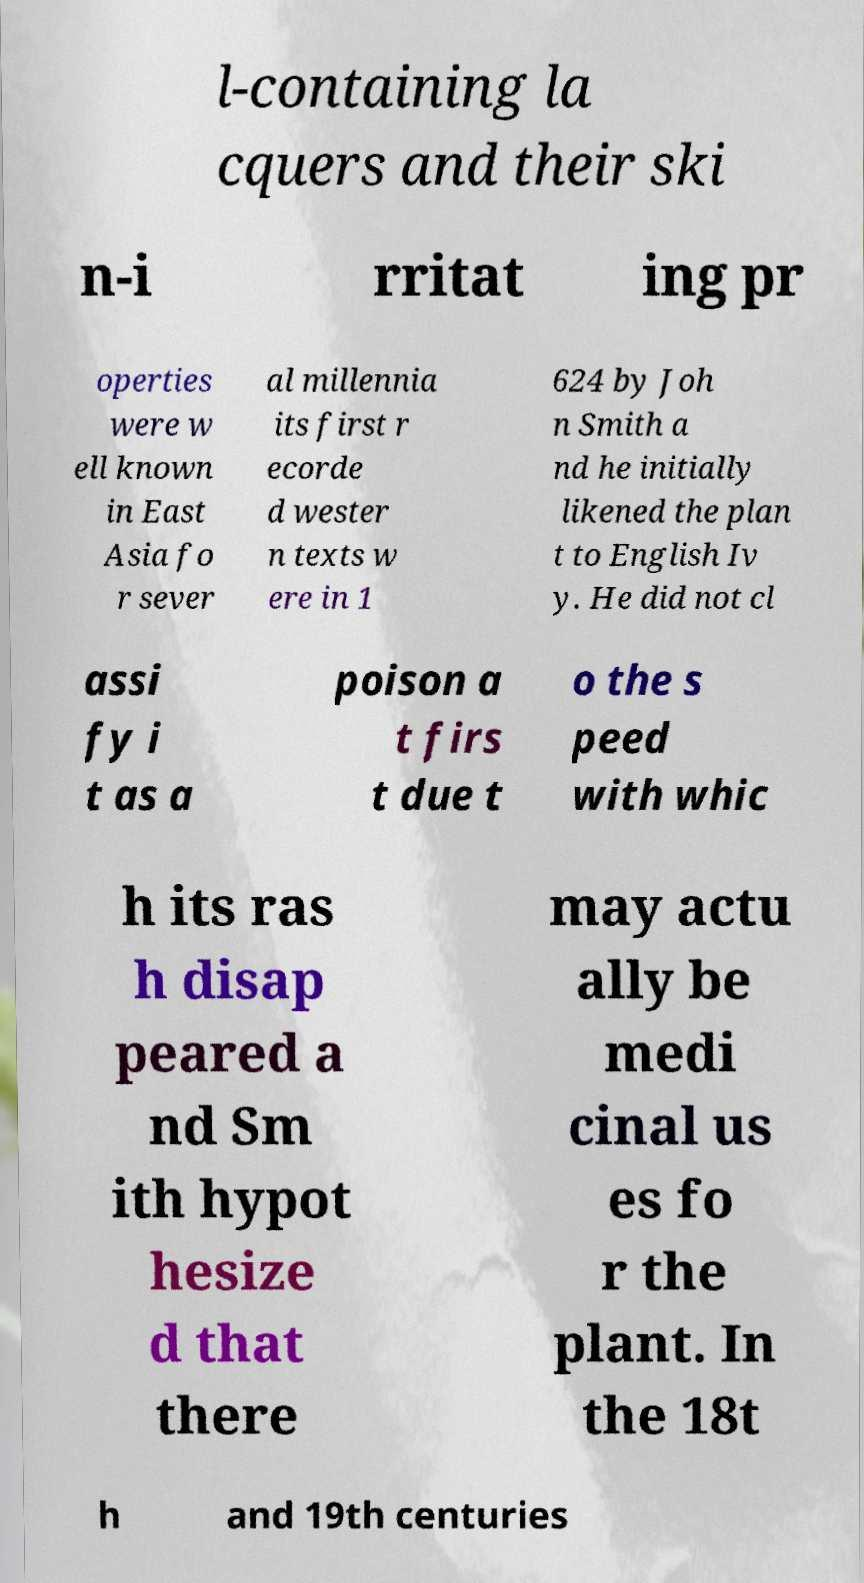Please read and relay the text visible in this image. What does it say? l-containing la cquers and their ski n-i rritat ing pr operties were w ell known in East Asia fo r sever al millennia its first r ecorde d wester n texts w ere in 1 624 by Joh n Smith a nd he initially likened the plan t to English Iv y. He did not cl assi fy i t as a poison a t firs t due t o the s peed with whic h its ras h disap peared a nd Sm ith hypot hesize d that there may actu ally be medi cinal us es fo r the plant. In the 18t h and 19th centuries 